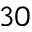<formula> <loc_0><loc_0><loc_500><loc_500>3 0</formula> 